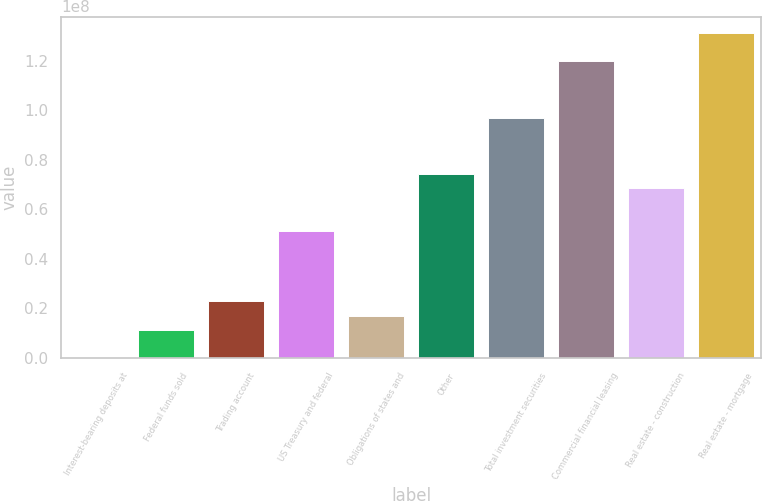<chart> <loc_0><loc_0><loc_500><loc_500><bar_chart><fcel>Interest-bearing deposits at<fcel>Federal funds sold<fcel>Trading account<fcel>US Treasury and federal<fcel>Obligations of states and<fcel>Other<fcel>Total investment securities<fcel>Commercial financial leasing<fcel>Real estate - construction<fcel>Real estate - mortgage<nl><fcel>6639<fcel>1.14183e+07<fcel>2.28299e+07<fcel>5.13591e+07<fcel>1.71241e+07<fcel>7.41824e+07<fcel>9.70057e+07<fcel>1.19829e+08<fcel>6.84766e+07<fcel>1.31241e+08<nl></chart> 